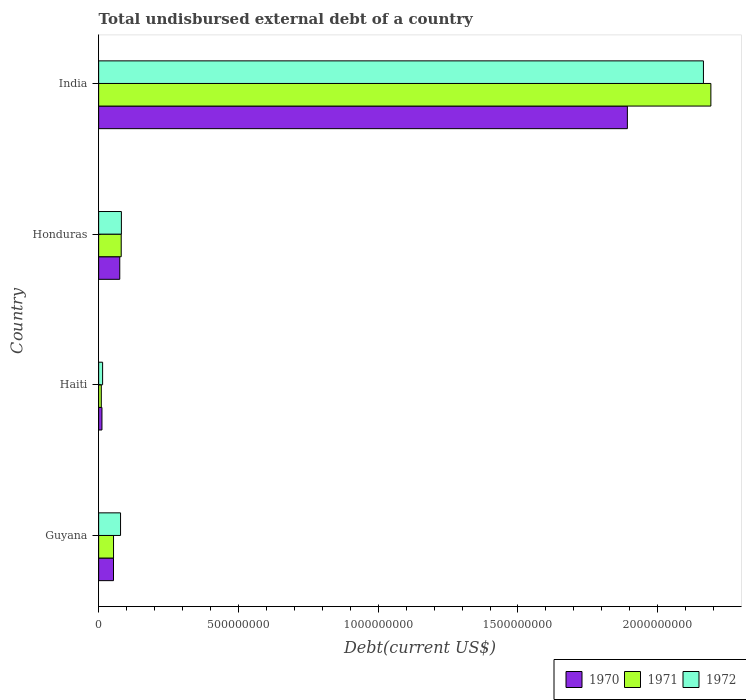What is the label of the 4th group of bars from the top?
Provide a succinct answer. Guyana. In how many cases, is the number of bars for a given country not equal to the number of legend labels?
Offer a terse response. 0. What is the total undisbursed external debt in 1970 in India?
Make the answer very short. 1.89e+09. Across all countries, what is the maximum total undisbursed external debt in 1970?
Offer a terse response. 1.89e+09. Across all countries, what is the minimum total undisbursed external debt in 1970?
Your response must be concise. 1.19e+07. In which country was the total undisbursed external debt in 1971 maximum?
Offer a very short reply. India. In which country was the total undisbursed external debt in 1970 minimum?
Offer a terse response. Haiti. What is the total total undisbursed external debt in 1970 in the graph?
Provide a short and direct response. 2.03e+09. What is the difference between the total undisbursed external debt in 1971 in Haiti and that in Honduras?
Provide a short and direct response. -7.13e+07. What is the difference between the total undisbursed external debt in 1972 in India and the total undisbursed external debt in 1970 in Haiti?
Provide a succinct answer. 2.15e+09. What is the average total undisbursed external debt in 1971 per country?
Ensure brevity in your answer.  5.83e+08. What is the difference between the total undisbursed external debt in 1970 and total undisbursed external debt in 1972 in Honduras?
Ensure brevity in your answer.  -5.80e+06. What is the ratio of the total undisbursed external debt in 1970 in Haiti to that in Honduras?
Offer a very short reply. 0.16. What is the difference between the highest and the second highest total undisbursed external debt in 1970?
Give a very brief answer. 1.82e+09. What is the difference between the highest and the lowest total undisbursed external debt in 1971?
Make the answer very short. 2.18e+09. What does the 1st bar from the top in India represents?
Keep it short and to the point. 1972. Is it the case that in every country, the sum of the total undisbursed external debt in 1972 and total undisbursed external debt in 1971 is greater than the total undisbursed external debt in 1970?
Give a very brief answer. Yes. How many countries are there in the graph?
Your answer should be compact. 4. What is the difference between two consecutive major ticks on the X-axis?
Keep it short and to the point. 5.00e+08. Does the graph contain any zero values?
Provide a succinct answer. No. Where does the legend appear in the graph?
Offer a terse response. Bottom right. How are the legend labels stacked?
Provide a short and direct response. Horizontal. What is the title of the graph?
Ensure brevity in your answer.  Total undisbursed external debt of a country. What is the label or title of the X-axis?
Your answer should be compact. Debt(current US$). What is the Debt(current US$) in 1970 in Guyana?
Provide a succinct answer. 5.32e+07. What is the Debt(current US$) in 1971 in Guyana?
Make the answer very short. 5.33e+07. What is the Debt(current US$) of 1972 in Guyana?
Provide a succinct answer. 7.84e+07. What is the Debt(current US$) in 1970 in Haiti?
Offer a terse response. 1.19e+07. What is the Debt(current US$) of 1971 in Haiti?
Offer a terse response. 9.53e+06. What is the Debt(current US$) of 1972 in Haiti?
Keep it short and to the point. 1.42e+07. What is the Debt(current US$) of 1970 in Honduras?
Your answer should be very brief. 7.56e+07. What is the Debt(current US$) of 1971 in Honduras?
Your response must be concise. 8.08e+07. What is the Debt(current US$) of 1972 in Honduras?
Provide a succinct answer. 8.14e+07. What is the Debt(current US$) in 1970 in India?
Your answer should be compact. 1.89e+09. What is the Debt(current US$) in 1971 in India?
Offer a very short reply. 2.19e+09. What is the Debt(current US$) of 1972 in India?
Your response must be concise. 2.16e+09. Across all countries, what is the maximum Debt(current US$) of 1970?
Ensure brevity in your answer.  1.89e+09. Across all countries, what is the maximum Debt(current US$) in 1971?
Your answer should be compact. 2.19e+09. Across all countries, what is the maximum Debt(current US$) of 1972?
Ensure brevity in your answer.  2.16e+09. Across all countries, what is the minimum Debt(current US$) in 1970?
Provide a short and direct response. 1.19e+07. Across all countries, what is the minimum Debt(current US$) in 1971?
Your answer should be compact. 9.53e+06. Across all countries, what is the minimum Debt(current US$) of 1972?
Ensure brevity in your answer.  1.42e+07. What is the total Debt(current US$) in 1970 in the graph?
Ensure brevity in your answer.  2.03e+09. What is the total Debt(current US$) of 1971 in the graph?
Offer a terse response. 2.33e+09. What is the total Debt(current US$) of 1972 in the graph?
Provide a short and direct response. 2.34e+09. What is the difference between the Debt(current US$) of 1970 in Guyana and that in Haiti?
Provide a succinct answer. 4.13e+07. What is the difference between the Debt(current US$) of 1971 in Guyana and that in Haiti?
Your answer should be very brief. 4.37e+07. What is the difference between the Debt(current US$) in 1972 in Guyana and that in Haiti?
Offer a terse response. 6.42e+07. What is the difference between the Debt(current US$) in 1970 in Guyana and that in Honduras?
Offer a very short reply. -2.24e+07. What is the difference between the Debt(current US$) of 1971 in Guyana and that in Honduras?
Your response must be concise. -2.75e+07. What is the difference between the Debt(current US$) of 1972 in Guyana and that in Honduras?
Provide a succinct answer. -3.05e+06. What is the difference between the Debt(current US$) in 1970 in Guyana and that in India?
Your answer should be very brief. -1.84e+09. What is the difference between the Debt(current US$) of 1971 in Guyana and that in India?
Ensure brevity in your answer.  -2.14e+09. What is the difference between the Debt(current US$) in 1972 in Guyana and that in India?
Keep it short and to the point. -2.09e+09. What is the difference between the Debt(current US$) in 1970 in Haiti and that in Honduras?
Ensure brevity in your answer.  -6.37e+07. What is the difference between the Debt(current US$) of 1971 in Haiti and that in Honduras?
Give a very brief answer. -7.13e+07. What is the difference between the Debt(current US$) of 1972 in Haiti and that in Honduras?
Offer a terse response. -6.72e+07. What is the difference between the Debt(current US$) of 1970 in Haiti and that in India?
Offer a terse response. -1.88e+09. What is the difference between the Debt(current US$) of 1971 in Haiti and that in India?
Offer a very short reply. -2.18e+09. What is the difference between the Debt(current US$) of 1972 in Haiti and that in India?
Give a very brief answer. -2.15e+09. What is the difference between the Debt(current US$) of 1970 in Honduras and that in India?
Offer a very short reply. -1.82e+09. What is the difference between the Debt(current US$) of 1971 in Honduras and that in India?
Offer a terse response. -2.11e+09. What is the difference between the Debt(current US$) of 1972 in Honduras and that in India?
Make the answer very short. -2.08e+09. What is the difference between the Debt(current US$) of 1970 in Guyana and the Debt(current US$) of 1971 in Haiti?
Provide a succinct answer. 4.37e+07. What is the difference between the Debt(current US$) in 1970 in Guyana and the Debt(current US$) in 1972 in Haiti?
Provide a short and direct response. 3.90e+07. What is the difference between the Debt(current US$) in 1971 in Guyana and the Debt(current US$) in 1972 in Haiti?
Give a very brief answer. 3.91e+07. What is the difference between the Debt(current US$) of 1970 in Guyana and the Debt(current US$) of 1971 in Honduras?
Keep it short and to the point. -2.76e+07. What is the difference between the Debt(current US$) of 1970 in Guyana and the Debt(current US$) of 1972 in Honduras?
Make the answer very short. -2.82e+07. What is the difference between the Debt(current US$) of 1971 in Guyana and the Debt(current US$) of 1972 in Honduras?
Keep it short and to the point. -2.82e+07. What is the difference between the Debt(current US$) in 1970 in Guyana and the Debt(current US$) in 1971 in India?
Your answer should be very brief. -2.14e+09. What is the difference between the Debt(current US$) in 1970 in Guyana and the Debt(current US$) in 1972 in India?
Keep it short and to the point. -2.11e+09. What is the difference between the Debt(current US$) in 1971 in Guyana and the Debt(current US$) in 1972 in India?
Offer a terse response. -2.11e+09. What is the difference between the Debt(current US$) of 1970 in Haiti and the Debt(current US$) of 1971 in Honduras?
Your response must be concise. -6.89e+07. What is the difference between the Debt(current US$) of 1970 in Haiti and the Debt(current US$) of 1972 in Honduras?
Offer a very short reply. -6.96e+07. What is the difference between the Debt(current US$) of 1971 in Haiti and the Debt(current US$) of 1972 in Honduras?
Your response must be concise. -7.19e+07. What is the difference between the Debt(current US$) in 1970 in Haiti and the Debt(current US$) in 1971 in India?
Give a very brief answer. -2.18e+09. What is the difference between the Debt(current US$) of 1970 in Haiti and the Debt(current US$) of 1972 in India?
Offer a terse response. -2.15e+09. What is the difference between the Debt(current US$) of 1971 in Haiti and the Debt(current US$) of 1972 in India?
Give a very brief answer. -2.15e+09. What is the difference between the Debt(current US$) in 1970 in Honduras and the Debt(current US$) in 1971 in India?
Your answer should be compact. -2.11e+09. What is the difference between the Debt(current US$) of 1970 in Honduras and the Debt(current US$) of 1972 in India?
Offer a terse response. -2.09e+09. What is the difference between the Debt(current US$) of 1971 in Honduras and the Debt(current US$) of 1972 in India?
Offer a terse response. -2.08e+09. What is the average Debt(current US$) in 1970 per country?
Your answer should be compact. 5.08e+08. What is the average Debt(current US$) of 1971 per country?
Give a very brief answer. 5.83e+08. What is the average Debt(current US$) of 1972 per country?
Provide a succinct answer. 5.84e+08. What is the difference between the Debt(current US$) in 1970 and Debt(current US$) in 1971 in Guyana?
Give a very brief answer. -7.30e+04. What is the difference between the Debt(current US$) of 1970 and Debt(current US$) of 1972 in Guyana?
Keep it short and to the point. -2.52e+07. What is the difference between the Debt(current US$) of 1971 and Debt(current US$) of 1972 in Guyana?
Keep it short and to the point. -2.51e+07. What is the difference between the Debt(current US$) of 1970 and Debt(current US$) of 1971 in Haiti?
Keep it short and to the point. 2.35e+06. What is the difference between the Debt(current US$) in 1970 and Debt(current US$) in 1972 in Haiti?
Provide a short and direct response. -2.33e+06. What is the difference between the Debt(current US$) of 1971 and Debt(current US$) of 1972 in Haiti?
Your answer should be very brief. -4.68e+06. What is the difference between the Debt(current US$) of 1970 and Debt(current US$) of 1971 in Honduras?
Provide a short and direct response. -5.20e+06. What is the difference between the Debt(current US$) of 1970 and Debt(current US$) of 1972 in Honduras?
Offer a terse response. -5.80e+06. What is the difference between the Debt(current US$) in 1971 and Debt(current US$) in 1972 in Honduras?
Your response must be concise. -6.09e+05. What is the difference between the Debt(current US$) in 1970 and Debt(current US$) in 1971 in India?
Keep it short and to the point. -2.99e+08. What is the difference between the Debt(current US$) in 1970 and Debt(current US$) in 1972 in India?
Your response must be concise. -2.72e+08. What is the difference between the Debt(current US$) of 1971 and Debt(current US$) of 1972 in India?
Provide a short and direct response. 2.66e+07. What is the ratio of the Debt(current US$) in 1970 in Guyana to that in Haiti?
Your response must be concise. 4.48. What is the ratio of the Debt(current US$) of 1971 in Guyana to that in Haiti?
Make the answer very short. 5.59. What is the ratio of the Debt(current US$) of 1972 in Guyana to that in Haiti?
Your answer should be very brief. 5.52. What is the ratio of the Debt(current US$) in 1970 in Guyana to that in Honduras?
Provide a short and direct response. 0.7. What is the ratio of the Debt(current US$) of 1971 in Guyana to that in Honduras?
Provide a short and direct response. 0.66. What is the ratio of the Debt(current US$) of 1972 in Guyana to that in Honduras?
Offer a very short reply. 0.96. What is the ratio of the Debt(current US$) in 1970 in Guyana to that in India?
Offer a very short reply. 0.03. What is the ratio of the Debt(current US$) of 1971 in Guyana to that in India?
Offer a very short reply. 0.02. What is the ratio of the Debt(current US$) in 1972 in Guyana to that in India?
Ensure brevity in your answer.  0.04. What is the ratio of the Debt(current US$) in 1970 in Haiti to that in Honduras?
Your answer should be compact. 0.16. What is the ratio of the Debt(current US$) in 1971 in Haiti to that in Honduras?
Keep it short and to the point. 0.12. What is the ratio of the Debt(current US$) of 1972 in Haiti to that in Honduras?
Offer a terse response. 0.17. What is the ratio of the Debt(current US$) in 1970 in Haiti to that in India?
Offer a very short reply. 0.01. What is the ratio of the Debt(current US$) of 1971 in Haiti to that in India?
Provide a succinct answer. 0. What is the ratio of the Debt(current US$) in 1972 in Haiti to that in India?
Provide a succinct answer. 0.01. What is the ratio of the Debt(current US$) of 1971 in Honduras to that in India?
Your answer should be compact. 0.04. What is the ratio of the Debt(current US$) of 1972 in Honduras to that in India?
Provide a succinct answer. 0.04. What is the difference between the highest and the second highest Debt(current US$) in 1970?
Ensure brevity in your answer.  1.82e+09. What is the difference between the highest and the second highest Debt(current US$) of 1971?
Your answer should be compact. 2.11e+09. What is the difference between the highest and the second highest Debt(current US$) in 1972?
Provide a succinct answer. 2.08e+09. What is the difference between the highest and the lowest Debt(current US$) of 1970?
Give a very brief answer. 1.88e+09. What is the difference between the highest and the lowest Debt(current US$) of 1971?
Your answer should be compact. 2.18e+09. What is the difference between the highest and the lowest Debt(current US$) in 1972?
Ensure brevity in your answer.  2.15e+09. 